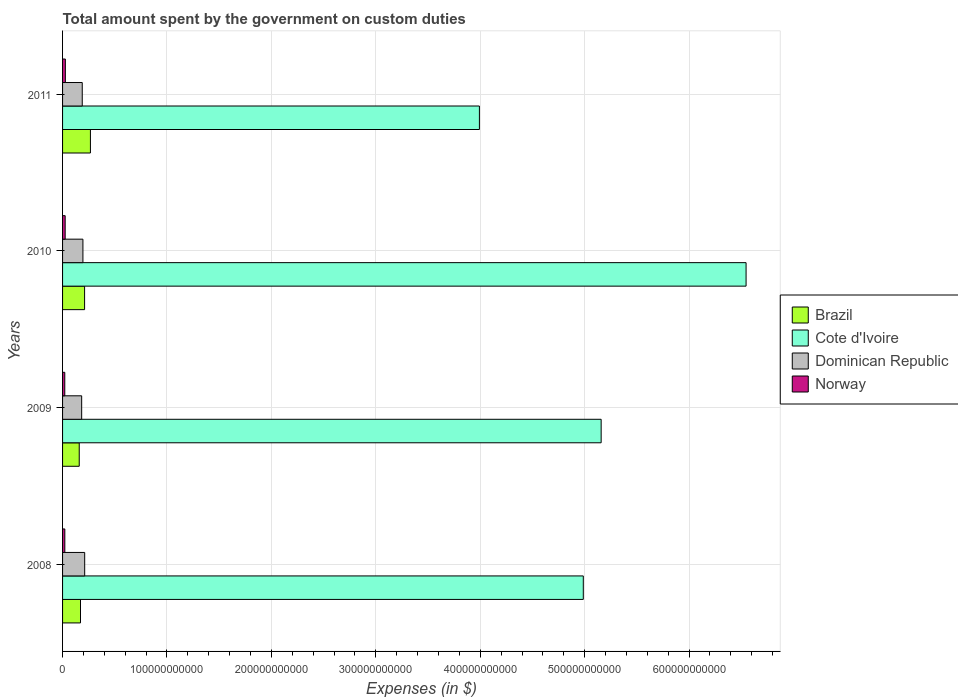How many different coloured bars are there?
Your answer should be compact. 4. Are the number of bars per tick equal to the number of legend labels?
Provide a succinct answer. Yes. Are the number of bars on each tick of the Y-axis equal?
Provide a succinct answer. Yes. How many bars are there on the 3rd tick from the top?
Provide a succinct answer. 4. What is the amount spent on custom duties by the government in Dominican Republic in 2011?
Provide a succinct answer. 1.89e+1. Across all years, what is the maximum amount spent on custom duties by the government in Dominican Republic?
Keep it short and to the point. 2.12e+1. Across all years, what is the minimum amount spent on custom duties by the government in Brazil?
Keep it short and to the point. 1.60e+1. In which year was the amount spent on custom duties by the government in Norway maximum?
Offer a terse response. 2011. In which year was the amount spent on custom duties by the government in Cote d'Ivoire minimum?
Your response must be concise. 2011. What is the total amount spent on custom duties by the government in Brazil in the graph?
Your answer should be compact. 8.09e+1. What is the difference between the amount spent on custom duties by the government in Norway in 2009 and that in 2011?
Your answer should be very brief. -5.60e+08. What is the difference between the amount spent on custom duties by the government in Dominican Republic in 2010 and the amount spent on custom duties by the government in Norway in 2008?
Provide a succinct answer. 1.73e+1. What is the average amount spent on custom duties by the government in Norway per year?
Give a very brief answer. 2.37e+09. In the year 2008, what is the difference between the amount spent on custom duties by the government in Dominican Republic and amount spent on custom duties by the government in Brazil?
Give a very brief answer. 4.01e+09. What is the ratio of the amount spent on custom duties by the government in Dominican Republic in 2008 to that in 2009?
Your response must be concise. 1.16. Is the amount spent on custom duties by the government in Brazil in 2008 less than that in 2009?
Ensure brevity in your answer.  No. Is the difference between the amount spent on custom duties by the government in Dominican Republic in 2009 and 2011 greater than the difference between the amount spent on custom duties by the government in Brazil in 2009 and 2011?
Provide a short and direct response. Yes. What is the difference between the highest and the second highest amount spent on custom duties by the government in Cote d'Ivoire?
Keep it short and to the point. 1.39e+11. What is the difference between the highest and the lowest amount spent on custom duties by the government in Cote d'Ivoire?
Offer a very short reply. 2.55e+11. In how many years, is the amount spent on custom duties by the government in Dominican Republic greater than the average amount spent on custom duties by the government in Dominican Republic taken over all years?
Offer a terse response. 2. Is the sum of the amount spent on custom duties by the government in Dominican Republic in 2009 and 2010 greater than the maximum amount spent on custom duties by the government in Cote d'Ivoire across all years?
Your response must be concise. No. What does the 3rd bar from the bottom in 2011 represents?
Ensure brevity in your answer.  Dominican Republic. Is it the case that in every year, the sum of the amount spent on custom duties by the government in Brazil and amount spent on custom duties by the government in Dominican Republic is greater than the amount spent on custom duties by the government in Cote d'Ivoire?
Provide a short and direct response. No. How many years are there in the graph?
Offer a terse response. 4. What is the difference between two consecutive major ticks on the X-axis?
Make the answer very short. 1.00e+11. How many legend labels are there?
Make the answer very short. 4. What is the title of the graph?
Make the answer very short. Total amount spent by the government on custom duties. Does "Bosnia and Herzegovina" appear as one of the legend labels in the graph?
Ensure brevity in your answer.  No. What is the label or title of the X-axis?
Your response must be concise. Expenses (in $). What is the Expenses (in $) in Brazil in 2008?
Provide a short and direct response. 1.72e+1. What is the Expenses (in $) in Cote d'Ivoire in 2008?
Your answer should be compact. 4.99e+11. What is the Expenses (in $) of Dominican Republic in 2008?
Keep it short and to the point. 2.12e+1. What is the Expenses (in $) in Norway in 2008?
Provide a succinct answer. 2.17e+09. What is the Expenses (in $) in Brazil in 2009?
Your answer should be compact. 1.60e+1. What is the Expenses (in $) of Cote d'Ivoire in 2009?
Provide a succinct answer. 5.16e+11. What is the Expenses (in $) in Dominican Republic in 2009?
Offer a terse response. 1.83e+1. What is the Expenses (in $) in Norway in 2009?
Provide a succinct answer. 2.12e+09. What is the Expenses (in $) in Brazil in 2010?
Offer a very short reply. 2.11e+1. What is the Expenses (in $) in Cote d'Ivoire in 2010?
Provide a short and direct response. 6.55e+11. What is the Expenses (in $) of Dominican Republic in 2010?
Your response must be concise. 1.95e+1. What is the Expenses (in $) in Norway in 2010?
Offer a very short reply. 2.50e+09. What is the Expenses (in $) of Brazil in 2011?
Offer a very short reply. 2.67e+1. What is the Expenses (in $) in Cote d'Ivoire in 2011?
Your response must be concise. 3.99e+11. What is the Expenses (in $) in Dominican Republic in 2011?
Offer a very short reply. 1.89e+1. What is the Expenses (in $) in Norway in 2011?
Offer a very short reply. 2.68e+09. Across all years, what is the maximum Expenses (in $) in Brazil?
Provide a short and direct response. 2.67e+1. Across all years, what is the maximum Expenses (in $) of Cote d'Ivoire?
Offer a terse response. 6.55e+11. Across all years, what is the maximum Expenses (in $) of Dominican Republic?
Offer a terse response. 2.12e+1. Across all years, what is the maximum Expenses (in $) in Norway?
Keep it short and to the point. 2.68e+09. Across all years, what is the minimum Expenses (in $) of Brazil?
Ensure brevity in your answer.  1.60e+1. Across all years, what is the minimum Expenses (in $) in Cote d'Ivoire?
Ensure brevity in your answer.  3.99e+11. Across all years, what is the minimum Expenses (in $) in Dominican Republic?
Your answer should be compact. 1.83e+1. Across all years, what is the minimum Expenses (in $) of Norway?
Ensure brevity in your answer.  2.12e+09. What is the total Expenses (in $) in Brazil in the graph?
Offer a very short reply. 8.09e+1. What is the total Expenses (in $) in Cote d'Ivoire in the graph?
Make the answer very short. 2.07e+12. What is the total Expenses (in $) in Dominican Republic in the graph?
Keep it short and to the point. 7.78e+1. What is the total Expenses (in $) in Norway in the graph?
Provide a short and direct response. 9.47e+09. What is the difference between the Expenses (in $) in Brazil in 2008 and that in 2009?
Offer a very short reply. 1.20e+09. What is the difference between the Expenses (in $) of Cote d'Ivoire in 2008 and that in 2009?
Your response must be concise. -1.71e+1. What is the difference between the Expenses (in $) of Dominican Republic in 2008 and that in 2009?
Give a very brief answer. 2.89e+09. What is the difference between the Expenses (in $) of Brazil in 2008 and that in 2010?
Keep it short and to the point. -3.92e+09. What is the difference between the Expenses (in $) in Cote d'Ivoire in 2008 and that in 2010?
Provide a short and direct response. -1.56e+11. What is the difference between the Expenses (in $) of Dominican Republic in 2008 and that in 2010?
Provide a succinct answer. 1.69e+09. What is the difference between the Expenses (in $) of Norway in 2008 and that in 2010?
Provide a short and direct response. -3.30e+08. What is the difference between the Expenses (in $) in Brazil in 2008 and that in 2011?
Your answer should be very brief. -9.51e+09. What is the difference between the Expenses (in $) in Cote d'Ivoire in 2008 and that in 2011?
Your response must be concise. 9.95e+1. What is the difference between the Expenses (in $) of Dominican Republic in 2008 and that in 2011?
Keep it short and to the point. 2.33e+09. What is the difference between the Expenses (in $) in Norway in 2008 and that in 2011?
Make the answer very short. -5.10e+08. What is the difference between the Expenses (in $) of Brazil in 2009 and that in 2010?
Your response must be concise. -5.13e+09. What is the difference between the Expenses (in $) in Cote d'Ivoire in 2009 and that in 2010?
Offer a terse response. -1.39e+11. What is the difference between the Expenses (in $) of Dominican Republic in 2009 and that in 2010?
Your answer should be compact. -1.20e+09. What is the difference between the Expenses (in $) in Norway in 2009 and that in 2010?
Keep it short and to the point. -3.80e+08. What is the difference between the Expenses (in $) in Brazil in 2009 and that in 2011?
Your response must be concise. -1.07e+1. What is the difference between the Expenses (in $) of Cote d'Ivoire in 2009 and that in 2011?
Provide a short and direct response. 1.17e+11. What is the difference between the Expenses (in $) of Dominican Republic in 2009 and that in 2011?
Offer a terse response. -5.57e+08. What is the difference between the Expenses (in $) of Norway in 2009 and that in 2011?
Your response must be concise. -5.60e+08. What is the difference between the Expenses (in $) of Brazil in 2010 and that in 2011?
Your answer should be very brief. -5.59e+09. What is the difference between the Expenses (in $) in Cote d'Ivoire in 2010 and that in 2011?
Your response must be concise. 2.55e+11. What is the difference between the Expenses (in $) of Dominican Republic in 2010 and that in 2011?
Provide a short and direct response. 6.41e+08. What is the difference between the Expenses (in $) of Norway in 2010 and that in 2011?
Provide a succinct answer. -1.80e+08. What is the difference between the Expenses (in $) of Brazil in 2008 and the Expenses (in $) of Cote d'Ivoire in 2009?
Keep it short and to the point. -4.99e+11. What is the difference between the Expenses (in $) in Brazil in 2008 and the Expenses (in $) in Dominican Republic in 2009?
Give a very brief answer. -1.12e+09. What is the difference between the Expenses (in $) of Brazil in 2008 and the Expenses (in $) of Norway in 2009?
Give a very brief answer. 1.51e+1. What is the difference between the Expenses (in $) of Cote d'Ivoire in 2008 and the Expenses (in $) of Dominican Republic in 2009?
Your answer should be compact. 4.80e+11. What is the difference between the Expenses (in $) in Cote d'Ivoire in 2008 and the Expenses (in $) in Norway in 2009?
Your response must be concise. 4.97e+11. What is the difference between the Expenses (in $) of Dominican Republic in 2008 and the Expenses (in $) of Norway in 2009?
Provide a succinct answer. 1.91e+1. What is the difference between the Expenses (in $) of Brazil in 2008 and the Expenses (in $) of Cote d'Ivoire in 2010?
Give a very brief answer. -6.37e+11. What is the difference between the Expenses (in $) of Brazil in 2008 and the Expenses (in $) of Dominican Republic in 2010?
Your response must be concise. -2.32e+09. What is the difference between the Expenses (in $) in Brazil in 2008 and the Expenses (in $) in Norway in 2010?
Your response must be concise. 1.47e+1. What is the difference between the Expenses (in $) in Cote d'Ivoire in 2008 and the Expenses (in $) in Dominican Republic in 2010?
Provide a succinct answer. 4.79e+11. What is the difference between the Expenses (in $) of Cote d'Ivoire in 2008 and the Expenses (in $) of Norway in 2010?
Provide a short and direct response. 4.96e+11. What is the difference between the Expenses (in $) in Dominican Republic in 2008 and the Expenses (in $) in Norway in 2010?
Your answer should be compact. 1.87e+1. What is the difference between the Expenses (in $) of Brazil in 2008 and the Expenses (in $) of Cote d'Ivoire in 2011?
Ensure brevity in your answer.  -3.82e+11. What is the difference between the Expenses (in $) of Brazil in 2008 and the Expenses (in $) of Dominican Republic in 2011?
Offer a terse response. -1.68e+09. What is the difference between the Expenses (in $) in Brazil in 2008 and the Expenses (in $) in Norway in 2011?
Make the answer very short. 1.45e+1. What is the difference between the Expenses (in $) of Cote d'Ivoire in 2008 and the Expenses (in $) of Dominican Republic in 2011?
Your answer should be very brief. 4.80e+11. What is the difference between the Expenses (in $) of Cote d'Ivoire in 2008 and the Expenses (in $) of Norway in 2011?
Your answer should be very brief. 4.96e+11. What is the difference between the Expenses (in $) in Dominican Republic in 2008 and the Expenses (in $) in Norway in 2011?
Provide a succinct answer. 1.85e+1. What is the difference between the Expenses (in $) of Brazil in 2009 and the Expenses (in $) of Cote d'Ivoire in 2010?
Make the answer very short. -6.39e+11. What is the difference between the Expenses (in $) of Brazil in 2009 and the Expenses (in $) of Dominican Republic in 2010?
Give a very brief answer. -3.52e+09. What is the difference between the Expenses (in $) of Brazil in 2009 and the Expenses (in $) of Norway in 2010?
Offer a terse response. 1.35e+1. What is the difference between the Expenses (in $) in Cote d'Ivoire in 2009 and the Expenses (in $) in Dominican Republic in 2010?
Provide a short and direct response. 4.96e+11. What is the difference between the Expenses (in $) of Cote d'Ivoire in 2009 and the Expenses (in $) of Norway in 2010?
Give a very brief answer. 5.13e+11. What is the difference between the Expenses (in $) in Dominican Republic in 2009 and the Expenses (in $) in Norway in 2010?
Your answer should be very brief. 1.58e+1. What is the difference between the Expenses (in $) of Brazil in 2009 and the Expenses (in $) of Cote d'Ivoire in 2011?
Your response must be concise. -3.83e+11. What is the difference between the Expenses (in $) in Brazil in 2009 and the Expenses (in $) in Dominican Republic in 2011?
Give a very brief answer. -2.88e+09. What is the difference between the Expenses (in $) of Brazil in 2009 and the Expenses (in $) of Norway in 2011?
Your answer should be compact. 1.33e+1. What is the difference between the Expenses (in $) in Cote d'Ivoire in 2009 and the Expenses (in $) in Dominican Republic in 2011?
Provide a succinct answer. 4.97e+11. What is the difference between the Expenses (in $) of Cote d'Ivoire in 2009 and the Expenses (in $) of Norway in 2011?
Your answer should be very brief. 5.13e+11. What is the difference between the Expenses (in $) in Dominican Republic in 2009 and the Expenses (in $) in Norway in 2011?
Provide a succinct answer. 1.56e+1. What is the difference between the Expenses (in $) in Brazil in 2010 and the Expenses (in $) in Cote d'Ivoire in 2011?
Make the answer very short. -3.78e+11. What is the difference between the Expenses (in $) of Brazil in 2010 and the Expenses (in $) of Dominican Republic in 2011?
Your answer should be compact. 2.24e+09. What is the difference between the Expenses (in $) of Brazil in 2010 and the Expenses (in $) of Norway in 2011?
Keep it short and to the point. 1.84e+1. What is the difference between the Expenses (in $) in Cote d'Ivoire in 2010 and the Expenses (in $) in Dominican Republic in 2011?
Your answer should be compact. 6.36e+11. What is the difference between the Expenses (in $) of Cote d'Ivoire in 2010 and the Expenses (in $) of Norway in 2011?
Give a very brief answer. 6.52e+11. What is the difference between the Expenses (in $) in Dominican Republic in 2010 and the Expenses (in $) in Norway in 2011?
Offer a terse response. 1.68e+1. What is the average Expenses (in $) of Brazil per year?
Your answer should be compact. 2.02e+1. What is the average Expenses (in $) in Cote d'Ivoire per year?
Your response must be concise. 5.17e+11. What is the average Expenses (in $) in Dominican Republic per year?
Provide a short and direct response. 1.95e+1. What is the average Expenses (in $) of Norway per year?
Provide a short and direct response. 2.37e+09. In the year 2008, what is the difference between the Expenses (in $) of Brazil and Expenses (in $) of Cote d'Ivoire?
Your response must be concise. -4.82e+11. In the year 2008, what is the difference between the Expenses (in $) in Brazil and Expenses (in $) in Dominican Republic?
Offer a very short reply. -4.01e+09. In the year 2008, what is the difference between the Expenses (in $) in Brazil and Expenses (in $) in Norway?
Offer a terse response. 1.50e+1. In the year 2008, what is the difference between the Expenses (in $) of Cote d'Ivoire and Expenses (in $) of Dominican Republic?
Offer a terse response. 4.78e+11. In the year 2008, what is the difference between the Expenses (in $) in Cote d'Ivoire and Expenses (in $) in Norway?
Provide a short and direct response. 4.97e+11. In the year 2008, what is the difference between the Expenses (in $) in Dominican Republic and Expenses (in $) in Norway?
Offer a very short reply. 1.90e+1. In the year 2009, what is the difference between the Expenses (in $) in Brazil and Expenses (in $) in Cote d'Ivoire?
Make the answer very short. -5.00e+11. In the year 2009, what is the difference between the Expenses (in $) in Brazil and Expenses (in $) in Dominican Republic?
Provide a short and direct response. -2.33e+09. In the year 2009, what is the difference between the Expenses (in $) in Brazil and Expenses (in $) in Norway?
Your answer should be compact. 1.38e+1. In the year 2009, what is the difference between the Expenses (in $) of Cote d'Ivoire and Expenses (in $) of Dominican Republic?
Ensure brevity in your answer.  4.98e+11. In the year 2009, what is the difference between the Expenses (in $) of Cote d'Ivoire and Expenses (in $) of Norway?
Your response must be concise. 5.14e+11. In the year 2009, what is the difference between the Expenses (in $) in Dominican Republic and Expenses (in $) in Norway?
Keep it short and to the point. 1.62e+1. In the year 2010, what is the difference between the Expenses (in $) of Brazil and Expenses (in $) of Cote d'Ivoire?
Ensure brevity in your answer.  -6.34e+11. In the year 2010, what is the difference between the Expenses (in $) of Brazil and Expenses (in $) of Dominican Republic?
Your answer should be compact. 1.60e+09. In the year 2010, what is the difference between the Expenses (in $) of Brazil and Expenses (in $) of Norway?
Your answer should be very brief. 1.86e+1. In the year 2010, what is the difference between the Expenses (in $) in Cote d'Ivoire and Expenses (in $) in Dominican Republic?
Offer a terse response. 6.35e+11. In the year 2010, what is the difference between the Expenses (in $) of Cote d'Ivoire and Expenses (in $) of Norway?
Your response must be concise. 6.52e+11. In the year 2010, what is the difference between the Expenses (in $) in Dominican Republic and Expenses (in $) in Norway?
Your response must be concise. 1.70e+1. In the year 2011, what is the difference between the Expenses (in $) of Brazil and Expenses (in $) of Cote d'Ivoire?
Give a very brief answer. -3.73e+11. In the year 2011, what is the difference between the Expenses (in $) of Brazil and Expenses (in $) of Dominican Republic?
Make the answer very short. 7.83e+09. In the year 2011, what is the difference between the Expenses (in $) of Brazil and Expenses (in $) of Norway?
Give a very brief answer. 2.40e+1. In the year 2011, what is the difference between the Expenses (in $) in Cote d'Ivoire and Expenses (in $) in Dominican Republic?
Offer a very short reply. 3.80e+11. In the year 2011, what is the difference between the Expenses (in $) in Cote d'Ivoire and Expenses (in $) in Norway?
Your response must be concise. 3.97e+11. In the year 2011, what is the difference between the Expenses (in $) in Dominican Republic and Expenses (in $) in Norway?
Offer a terse response. 1.62e+1. What is the ratio of the Expenses (in $) in Brazil in 2008 to that in 2009?
Provide a succinct answer. 1.08. What is the ratio of the Expenses (in $) of Cote d'Ivoire in 2008 to that in 2009?
Your response must be concise. 0.97. What is the ratio of the Expenses (in $) of Dominican Republic in 2008 to that in 2009?
Ensure brevity in your answer.  1.16. What is the ratio of the Expenses (in $) in Norway in 2008 to that in 2009?
Provide a short and direct response. 1.02. What is the ratio of the Expenses (in $) of Brazil in 2008 to that in 2010?
Make the answer very short. 0.81. What is the ratio of the Expenses (in $) in Cote d'Ivoire in 2008 to that in 2010?
Your response must be concise. 0.76. What is the ratio of the Expenses (in $) in Dominican Republic in 2008 to that in 2010?
Provide a short and direct response. 1.09. What is the ratio of the Expenses (in $) of Norway in 2008 to that in 2010?
Keep it short and to the point. 0.87. What is the ratio of the Expenses (in $) in Brazil in 2008 to that in 2011?
Your answer should be compact. 0.64. What is the ratio of the Expenses (in $) of Cote d'Ivoire in 2008 to that in 2011?
Offer a terse response. 1.25. What is the ratio of the Expenses (in $) of Dominican Republic in 2008 to that in 2011?
Your response must be concise. 1.12. What is the ratio of the Expenses (in $) of Norway in 2008 to that in 2011?
Offer a very short reply. 0.81. What is the ratio of the Expenses (in $) in Brazil in 2009 to that in 2010?
Make the answer very short. 0.76. What is the ratio of the Expenses (in $) in Cote d'Ivoire in 2009 to that in 2010?
Ensure brevity in your answer.  0.79. What is the ratio of the Expenses (in $) of Dominican Republic in 2009 to that in 2010?
Ensure brevity in your answer.  0.94. What is the ratio of the Expenses (in $) of Norway in 2009 to that in 2010?
Make the answer very short. 0.85. What is the ratio of the Expenses (in $) of Brazil in 2009 to that in 2011?
Provide a short and direct response. 0.6. What is the ratio of the Expenses (in $) of Cote d'Ivoire in 2009 to that in 2011?
Offer a terse response. 1.29. What is the ratio of the Expenses (in $) of Dominican Republic in 2009 to that in 2011?
Keep it short and to the point. 0.97. What is the ratio of the Expenses (in $) in Norway in 2009 to that in 2011?
Ensure brevity in your answer.  0.79. What is the ratio of the Expenses (in $) in Brazil in 2010 to that in 2011?
Offer a terse response. 0.79. What is the ratio of the Expenses (in $) in Cote d'Ivoire in 2010 to that in 2011?
Make the answer very short. 1.64. What is the ratio of the Expenses (in $) in Dominican Republic in 2010 to that in 2011?
Offer a terse response. 1.03. What is the ratio of the Expenses (in $) in Norway in 2010 to that in 2011?
Your answer should be compact. 0.93. What is the difference between the highest and the second highest Expenses (in $) in Brazil?
Make the answer very short. 5.59e+09. What is the difference between the highest and the second highest Expenses (in $) of Cote d'Ivoire?
Your answer should be compact. 1.39e+11. What is the difference between the highest and the second highest Expenses (in $) in Dominican Republic?
Keep it short and to the point. 1.69e+09. What is the difference between the highest and the second highest Expenses (in $) of Norway?
Ensure brevity in your answer.  1.80e+08. What is the difference between the highest and the lowest Expenses (in $) of Brazil?
Ensure brevity in your answer.  1.07e+1. What is the difference between the highest and the lowest Expenses (in $) in Cote d'Ivoire?
Keep it short and to the point. 2.55e+11. What is the difference between the highest and the lowest Expenses (in $) in Dominican Republic?
Make the answer very short. 2.89e+09. What is the difference between the highest and the lowest Expenses (in $) of Norway?
Give a very brief answer. 5.60e+08. 